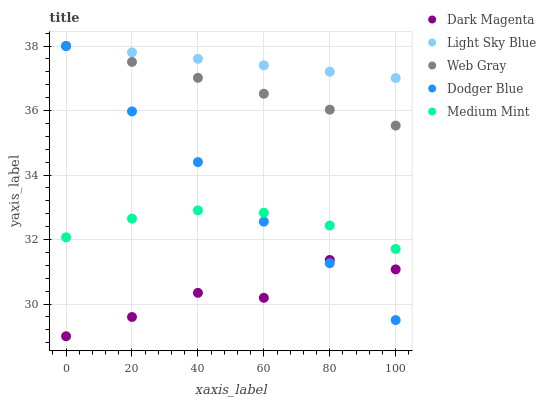Does Dark Magenta have the minimum area under the curve?
Answer yes or no. Yes. Does Light Sky Blue have the maximum area under the curve?
Answer yes or no. Yes. Does Dodger Blue have the minimum area under the curve?
Answer yes or no. No. Does Dodger Blue have the maximum area under the curve?
Answer yes or no. No. Is Light Sky Blue the smoothest?
Answer yes or no. Yes. Is Dark Magenta the roughest?
Answer yes or no. Yes. Is Dodger Blue the smoothest?
Answer yes or no. No. Is Dodger Blue the roughest?
Answer yes or no. No. Does Dark Magenta have the lowest value?
Answer yes or no. Yes. Does Dodger Blue have the lowest value?
Answer yes or no. No. Does Web Gray have the highest value?
Answer yes or no. Yes. Does Dark Magenta have the highest value?
Answer yes or no. No. Is Dark Magenta less than Medium Mint?
Answer yes or no. Yes. Is Web Gray greater than Dark Magenta?
Answer yes or no. Yes. Does Dodger Blue intersect Web Gray?
Answer yes or no. Yes. Is Dodger Blue less than Web Gray?
Answer yes or no. No. Is Dodger Blue greater than Web Gray?
Answer yes or no. No. Does Dark Magenta intersect Medium Mint?
Answer yes or no. No. 